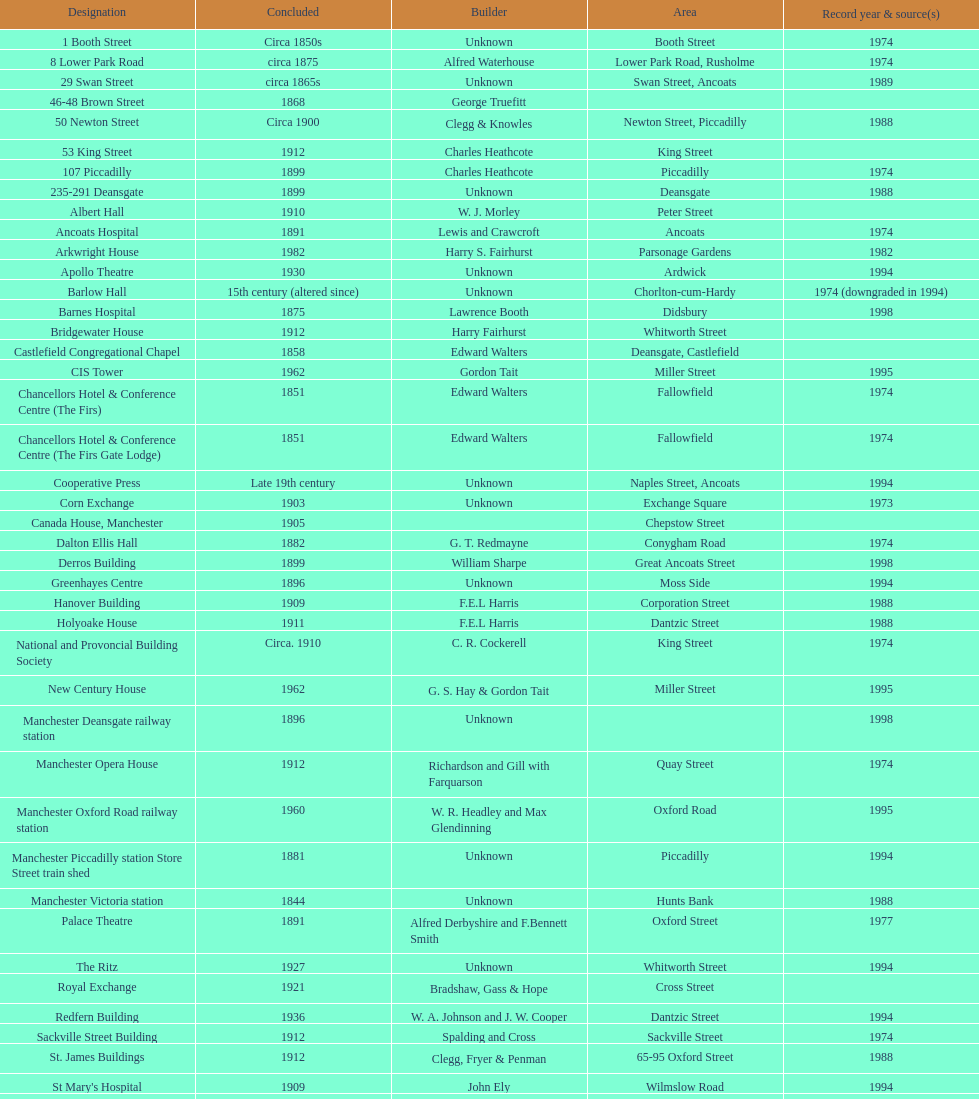What is the difference, in years, between the completion dates of 53 king street and castlefield congregational chapel? 54 years. 